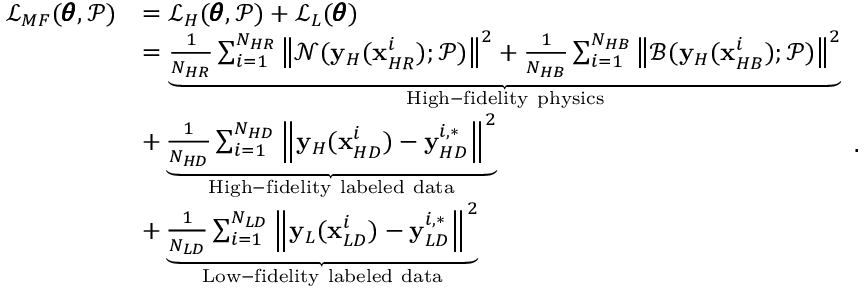Convert formula to latex. <formula><loc_0><loc_0><loc_500><loc_500>\begin{array} { r l } { \mathcal { L } _ { M F } ( \pm b { \theta } , \mathcal { P } ) } & { = \mathcal { L } _ { H } ( \pm b { \theta } , \mathcal { P } ) + \mathcal { L } _ { L } ( \pm b { \theta } ) } \\ & { = \underbrace { \frac { 1 } { N _ { H R } } \sum _ { i = 1 } ^ { N _ { H R } } { \left \| \mathcal { N } ( y _ { H } ( x _ { H R } ^ { i } ) ; \mathcal { P } ) \right \| ^ { 2 } } + \frac { 1 } { N _ { H B } } \sum _ { i = 1 } ^ { N _ { H B } } { \left \| \mathcal { B } ( y _ { H } ( x _ { H B } ^ { i } ) ; \mathcal { P } ) \right \| ^ { 2 } } } _ { H i g h - f i d e l i t y p h y s i c s } } \\ & { + \underbrace { \frac { 1 } { N _ { H D } } \sum _ { i = 1 } ^ { N _ { H D } } { \left \| y _ { H } ( x _ { H D } ^ { i } ) - y _ { H D } ^ { i , * } \right \| ^ { 2 } } } _ { H i g h - f i d e l i t y l a b e l e d d a t a } } \\ & { + \underbrace { \frac { 1 } { N _ { L D } } \sum _ { i = 1 } ^ { N _ { L D } } { \left \| y _ { L } ( x _ { L D } ^ { i } ) - y _ { L D } ^ { i , * } \right \| ^ { 2 } } } _ { L o w - f i d e l i t y l a b e l e d d a t a } } \end{array} .</formula> 